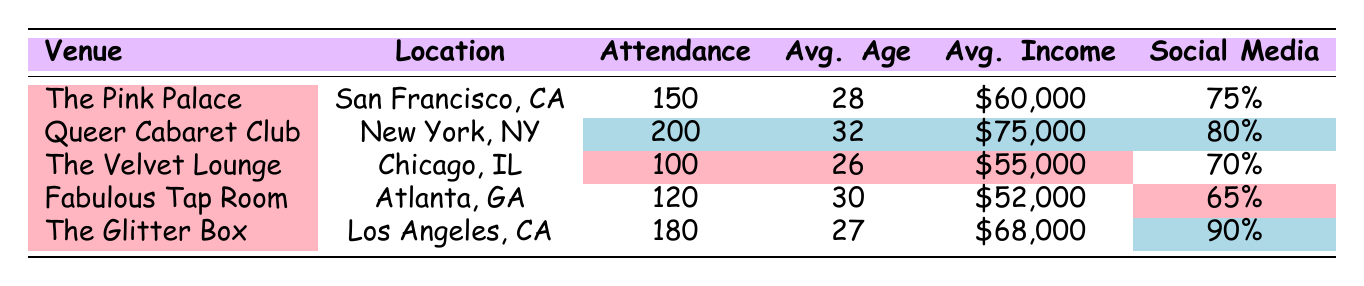What is the highest attendance recorded in the table? By looking at the attendance column, we can see that the highest value is 200 at the Queer Cabaret Club event.
Answer: 200 What is the average income for the audience at The Pink Palace? The average income for this venue is explicitly mentioned in the table as $60,000.
Answer: $60,000 What is the average age of the audience at The Velvet Lounge? The average age for this venue is given as 26 years, which is directly noted in the table.
Answer: 26 Which venue had the least social media engagement? The Fabulous Tap Room is marked with 65% for social media engagement, which is the lowest percentage in the table.
Answer: Fabulous Tap Room How many events had an attendance of 150 or more? There are four events listed with attendance figures: The Pink Palace (150), Queer Cabaret Club (200), The Glitter Box (180), and Fabulous Tap Room (120). Three of these events have attendance figures of 150 or more. Thus, the total number is three.
Answer: 3 What is the difference in average age between the oldest and youngest audiences? The oldest audience is at the Queer Cabaret Club with an average age of 32, and the youngest is at The Velvet Lounge with an average age of 26. The difference is 32 - 26 = 6 years.
Answer: 6 Is the average income for audiences in New York higher than in San Francisco? The average income in New York (Queer Cabaret Club) is $75,000, while in San Francisco (The Pink Palace) it is $60,000. Since $75,000 is greater than $60,000, the answer is yes.
Answer: Yes What is the total attendance of all events listed? By adding the attendance figures: 150 (The Pink Palace) + 200 (Queer Cabaret Club) + 100 (The Velvet Lounge) + 120 (Fabulous Tap Room) + 180 (The Glitter Box) = 850. The total attendance is 850.
Answer: 850 Which venue had the highest average income? Upon reviewing the average income column, the Queer Cabaret Club has the highest average income at $75,000.
Answer: Queer Cabaret Club Are there more male or female attendees overall when analyzing the gender distributions provided? Reviewing attendance and gender distribution: The Pink Palace (45 male, 45 female), Queer Cabaret Club (50 male, 35 female), The Velvet Lounge (40 male, 45 female), Fabulous Tap Room (30 male, 60 female), and The Glitter Box (55 male, 55 female). Summing these shows males total: 220 and females total: 235, indicating that there are more female attendees overall.
Answer: More female attendees 